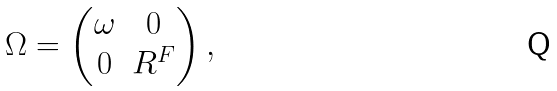<formula> <loc_0><loc_0><loc_500><loc_500>\Omega = \begin{pmatrix} \omega & 0 \\ 0 & R ^ { F } \end{pmatrix} ,</formula> 